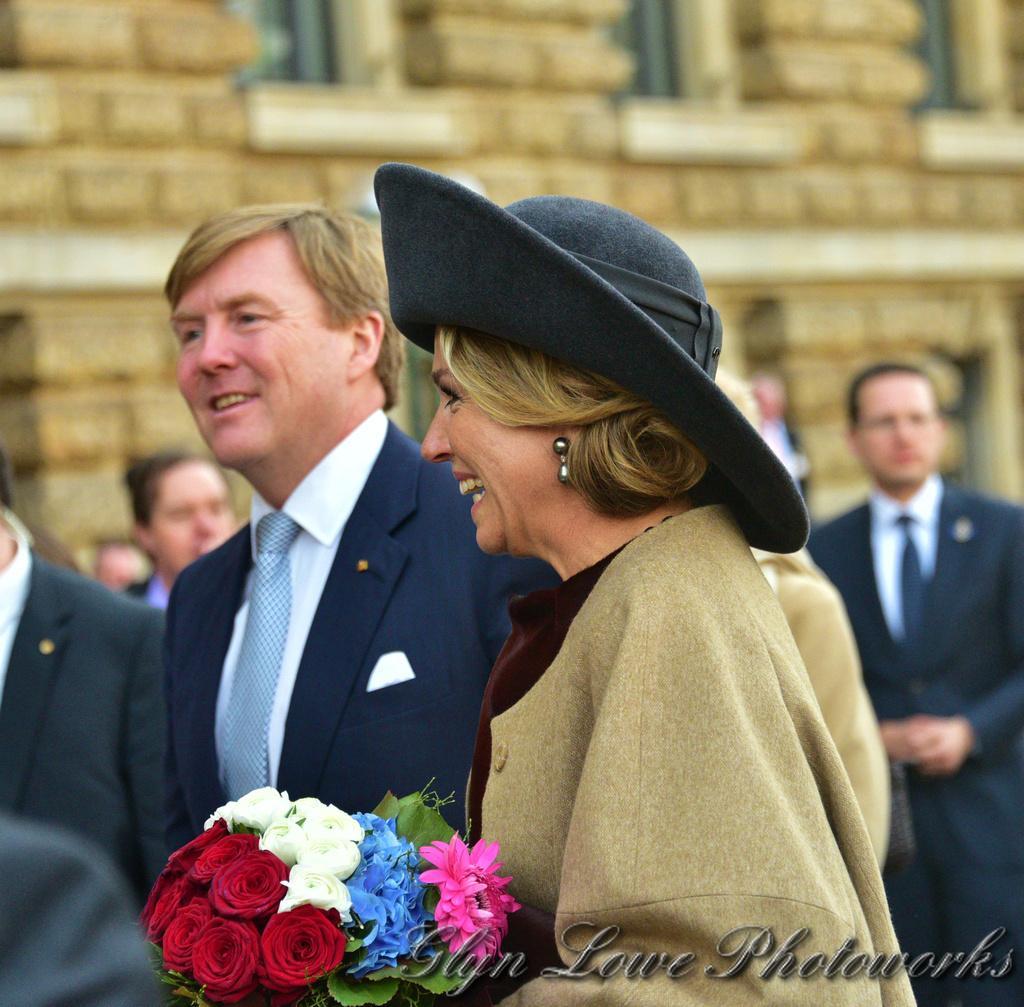Can you describe this image briefly? In this image there is a lady standing and holding a book in her hand, behind her there are a few people standing. In the background there is a building. At the bottom of the image there is some text. 